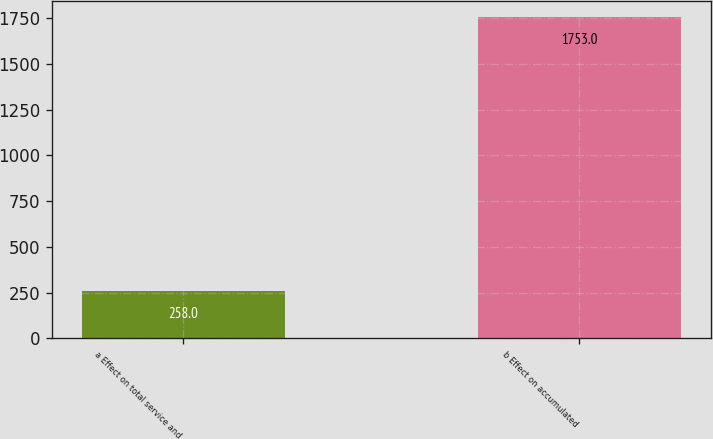Convert chart to OTSL. <chart><loc_0><loc_0><loc_500><loc_500><bar_chart><fcel>a Effect on total service and<fcel>b Effect on accumulated<nl><fcel>258<fcel>1753<nl></chart> 